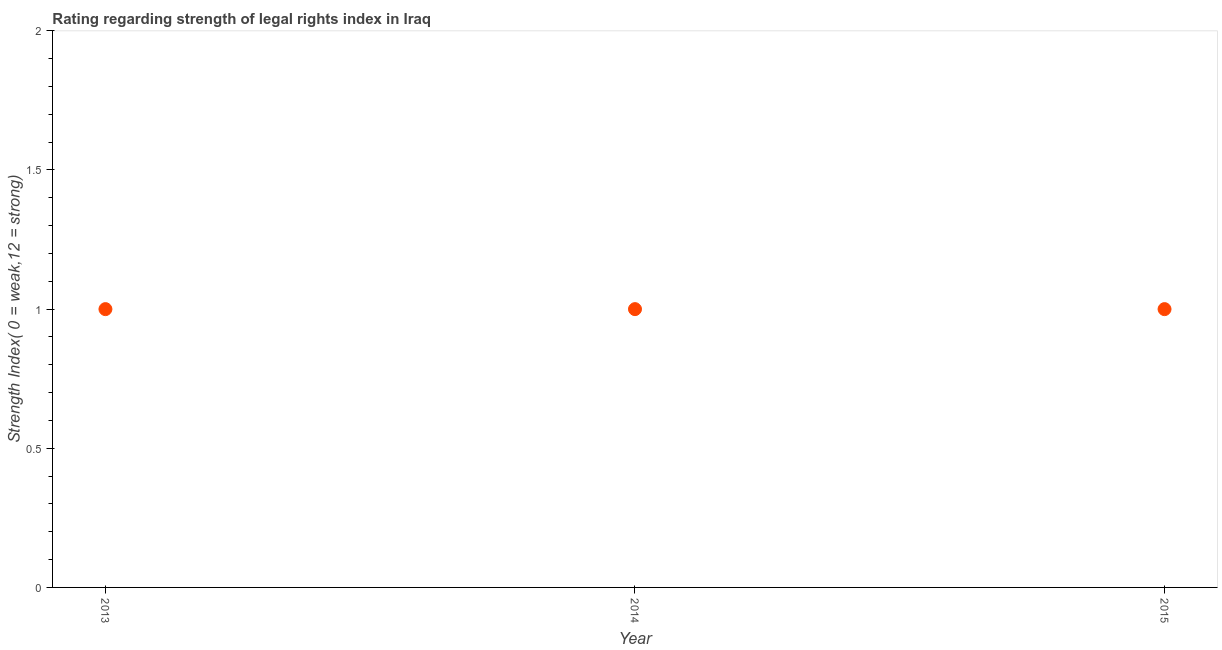What is the strength of legal rights index in 2014?
Ensure brevity in your answer.  1. Across all years, what is the maximum strength of legal rights index?
Offer a terse response. 1. Across all years, what is the minimum strength of legal rights index?
Your answer should be very brief. 1. In which year was the strength of legal rights index maximum?
Keep it short and to the point. 2013. In which year was the strength of legal rights index minimum?
Provide a short and direct response. 2013. What is the sum of the strength of legal rights index?
Your answer should be very brief. 3. What is the difference between the strength of legal rights index in 2013 and 2014?
Offer a very short reply. 0. What is the median strength of legal rights index?
Your answer should be very brief. 1. In how many years, is the strength of legal rights index greater than 0.2 ?
Your answer should be compact. 3. What is the ratio of the strength of legal rights index in 2013 to that in 2014?
Your response must be concise. 1. Is the strength of legal rights index in 2013 less than that in 2015?
Offer a terse response. No. Is the sum of the strength of legal rights index in 2013 and 2015 greater than the maximum strength of legal rights index across all years?
Provide a short and direct response. Yes. What is the difference between the highest and the lowest strength of legal rights index?
Keep it short and to the point. 0. In how many years, is the strength of legal rights index greater than the average strength of legal rights index taken over all years?
Keep it short and to the point. 0. How many dotlines are there?
Ensure brevity in your answer.  1. How many years are there in the graph?
Provide a succinct answer. 3. Does the graph contain grids?
Provide a short and direct response. No. What is the title of the graph?
Offer a terse response. Rating regarding strength of legal rights index in Iraq. What is the label or title of the Y-axis?
Provide a short and direct response. Strength Index( 0 = weak,12 = strong). What is the Strength Index( 0 = weak,12 = strong) in 2013?
Offer a very short reply. 1. What is the Strength Index( 0 = weak,12 = strong) in 2014?
Provide a succinct answer. 1. What is the Strength Index( 0 = weak,12 = strong) in 2015?
Provide a short and direct response. 1. What is the difference between the Strength Index( 0 = weak,12 = strong) in 2013 and 2015?
Provide a succinct answer. 0. 